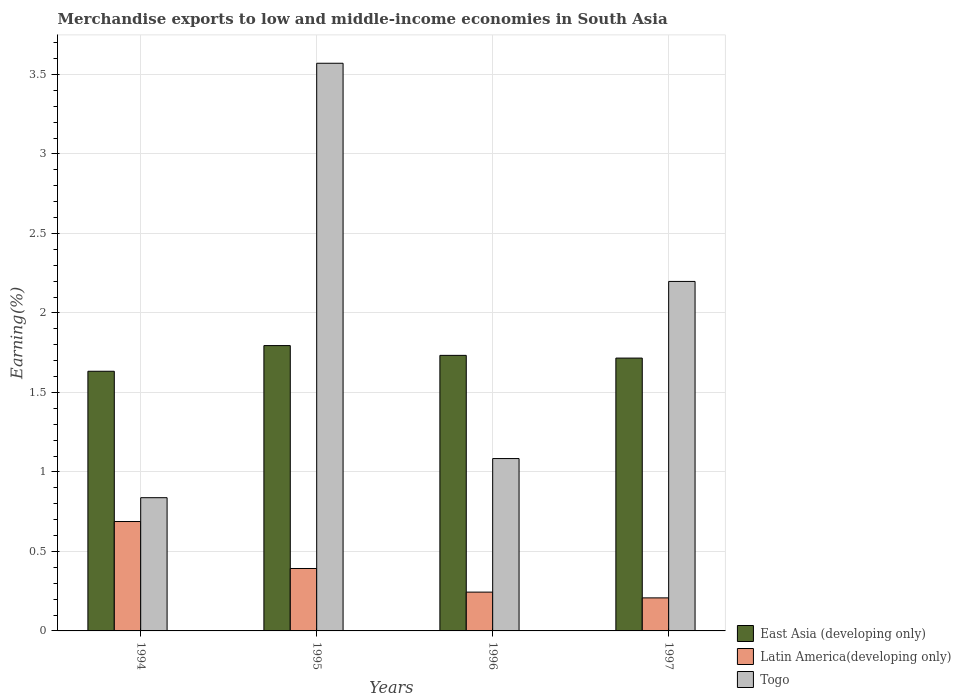How many groups of bars are there?
Offer a terse response. 4. What is the label of the 1st group of bars from the left?
Keep it short and to the point. 1994. In how many cases, is the number of bars for a given year not equal to the number of legend labels?
Offer a terse response. 0. What is the percentage of amount earned from merchandise exports in East Asia (developing only) in 1997?
Ensure brevity in your answer.  1.72. Across all years, what is the maximum percentage of amount earned from merchandise exports in Togo?
Ensure brevity in your answer.  3.57. Across all years, what is the minimum percentage of amount earned from merchandise exports in Latin America(developing only)?
Your response must be concise. 0.21. In which year was the percentage of amount earned from merchandise exports in East Asia (developing only) maximum?
Ensure brevity in your answer.  1995. What is the total percentage of amount earned from merchandise exports in East Asia (developing only) in the graph?
Provide a succinct answer. 6.88. What is the difference between the percentage of amount earned from merchandise exports in Latin America(developing only) in 1995 and that in 1997?
Provide a short and direct response. 0.18. What is the difference between the percentage of amount earned from merchandise exports in East Asia (developing only) in 1997 and the percentage of amount earned from merchandise exports in Latin America(developing only) in 1996?
Make the answer very short. 1.47. What is the average percentage of amount earned from merchandise exports in Latin America(developing only) per year?
Make the answer very short. 0.38. In the year 1995, what is the difference between the percentage of amount earned from merchandise exports in Latin America(developing only) and percentage of amount earned from merchandise exports in East Asia (developing only)?
Give a very brief answer. -1.4. In how many years, is the percentage of amount earned from merchandise exports in Togo greater than 2.2 %?
Your answer should be compact. 1. What is the ratio of the percentage of amount earned from merchandise exports in Latin America(developing only) in 1994 to that in 1995?
Offer a terse response. 1.75. What is the difference between the highest and the second highest percentage of amount earned from merchandise exports in Latin America(developing only)?
Your response must be concise. 0.3. What is the difference between the highest and the lowest percentage of amount earned from merchandise exports in Latin America(developing only)?
Make the answer very short. 0.48. In how many years, is the percentage of amount earned from merchandise exports in Togo greater than the average percentage of amount earned from merchandise exports in Togo taken over all years?
Keep it short and to the point. 2. Is the sum of the percentage of amount earned from merchandise exports in East Asia (developing only) in 1994 and 1995 greater than the maximum percentage of amount earned from merchandise exports in Togo across all years?
Keep it short and to the point. No. What does the 1st bar from the left in 1997 represents?
Your response must be concise. East Asia (developing only). What does the 3rd bar from the right in 1997 represents?
Your response must be concise. East Asia (developing only). How many years are there in the graph?
Your response must be concise. 4. Are the values on the major ticks of Y-axis written in scientific E-notation?
Your response must be concise. No. Does the graph contain any zero values?
Offer a terse response. No. Where does the legend appear in the graph?
Provide a short and direct response. Bottom right. How are the legend labels stacked?
Make the answer very short. Vertical. What is the title of the graph?
Provide a short and direct response. Merchandise exports to low and middle-income economies in South Asia. Does "Cabo Verde" appear as one of the legend labels in the graph?
Offer a very short reply. No. What is the label or title of the Y-axis?
Keep it short and to the point. Earning(%). What is the Earning(%) in East Asia (developing only) in 1994?
Your answer should be very brief. 1.63. What is the Earning(%) in Latin America(developing only) in 1994?
Offer a terse response. 0.69. What is the Earning(%) of Togo in 1994?
Provide a short and direct response. 0.84. What is the Earning(%) of East Asia (developing only) in 1995?
Make the answer very short. 1.79. What is the Earning(%) in Latin America(developing only) in 1995?
Offer a very short reply. 0.39. What is the Earning(%) of Togo in 1995?
Ensure brevity in your answer.  3.57. What is the Earning(%) of East Asia (developing only) in 1996?
Ensure brevity in your answer.  1.73. What is the Earning(%) of Latin America(developing only) in 1996?
Provide a succinct answer. 0.24. What is the Earning(%) of Togo in 1996?
Offer a very short reply. 1.08. What is the Earning(%) in East Asia (developing only) in 1997?
Offer a very short reply. 1.72. What is the Earning(%) of Latin America(developing only) in 1997?
Your answer should be compact. 0.21. What is the Earning(%) in Togo in 1997?
Provide a short and direct response. 2.2. Across all years, what is the maximum Earning(%) in East Asia (developing only)?
Your answer should be compact. 1.79. Across all years, what is the maximum Earning(%) of Latin America(developing only)?
Your answer should be very brief. 0.69. Across all years, what is the maximum Earning(%) of Togo?
Offer a terse response. 3.57. Across all years, what is the minimum Earning(%) of East Asia (developing only)?
Provide a succinct answer. 1.63. Across all years, what is the minimum Earning(%) of Latin America(developing only)?
Your response must be concise. 0.21. Across all years, what is the minimum Earning(%) in Togo?
Keep it short and to the point. 0.84. What is the total Earning(%) of East Asia (developing only) in the graph?
Give a very brief answer. 6.88. What is the total Earning(%) in Latin America(developing only) in the graph?
Your answer should be very brief. 1.53. What is the total Earning(%) in Togo in the graph?
Offer a terse response. 7.69. What is the difference between the Earning(%) of East Asia (developing only) in 1994 and that in 1995?
Offer a very short reply. -0.16. What is the difference between the Earning(%) of Latin America(developing only) in 1994 and that in 1995?
Your answer should be very brief. 0.3. What is the difference between the Earning(%) in Togo in 1994 and that in 1995?
Your answer should be very brief. -2.73. What is the difference between the Earning(%) of East Asia (developing only) in 1994 and that in 1996?
Offer a very short reply. -0.1. What is the difference between the Earning(%) of Latin America(developing only) in 1994 and that in 1996?
Make the answer very short. 0.44. What is the difference between the Earning(%) in Togo in 1994 and that in 1996?
Ensure brevity in your answer.  -0.25. What is the difference between the Earning(%) in East Asia (developing only) in 1994 and that in 1997?
Make the answer very short. -0.08. What is the difference between the Earning(%) in Latin America(developing only) in 1994 and that in 1997?
Give a very brief answer. 0.48. What is the difference between the Earning(%) of Togo in 1994 and that in 1997?
Your answer should be very brief. -1.36. What is the difference between the Earning(%) of East Asia (developing only) in 1995 and that in 1996?
Your answer should be compact. 0.06. What is the difference between the Earning(%) of Latin America(developing only) in 1995 and that in 1996?
Ensure brevity in your answer.  0.15. What is the difference between the Earning(%) of Togo in 1995 and that in 1996?
Your answer should be compact. 2.49. What is the difference between the Earning(%) of East Asia (developing only) in 1995 and that in 1997?
Your answer should be very brief. 0.08. What is the difference between the Earning(%) of Latin America(developing only) in 1995 and that in 1997?
Your answer should be compact. 0.18. What is the difference between the Earning(%) of Togo in 1995 and that in 1997?
Provide a succinct answer. 1.37. What is the difference between the Earning(%) of East Asia (developing only) in 1996 and that in 1997?
Your response must be concise. 0.02. What is the difference between the Earning(%) of Latin America(developing only) in 1996 and that in 1997?
Offer a very short reply. 0.04. What is the difference between the Earning(%) in Togo in 1996 and that in 1997?
Offer a very short reply. -1.11. What is the difference between the Earning(%) of East Asia (developing only) in 1994 and the Earning(%) of Latin America(developing only) in 1995?
Your answer should be compact. 1.24. What is the difference between the Earning(%) in East Asia (developing only) in 1994 and the Earning(%) in Togo in 1995?
Your answer should be very brief. -1.94. What is the difference between the Earning(%) in Latin America(developing only) in 1994 and the Earning(%) in Togo in 1995?
Make the answer very short. -2.88. What is the difference between the Earning(%) of East Asia (developing only) in 1994 and the Earning(%) of Latin America(developing only) in 1996?
Ensure brevity in your answer.  1.39. What is the difference between the Earning(%) in East Asia (developing only) in 1994 and the Earning(%) in Togo in 1996?
Ensure brevity in your answer.  0.55. What is the difference between the Earning(%) in Latin America(developing only) in 1994 and the Earning(%) in Togo in 1996?
Offer a very short reply. -0.4. What is the difference between the Earning(%) of East Asia (developing only) in 1994 and the Earning(%) of Latin America(developing only) in 1997?
Give a very brief answer. 1.43. What is the difference between the Earning(%) in East Asia (developing only) in 1994 and the Earning(%) in Togo in 1997?
Make the answer very short. -0.56. What is the difference between the Earning(%) of Latin America(developing only) in 1994 and the Earning(%) of Togo in 1997?
Your answer should be very brief. -1.51. What is the difference between the Earning(%) in East Asia (developing only) in 1995 and the Earning(%) in Latin America(developing only) in 1996?
Offer a very short reply. 1.55. What is the difference between the Earning(%) in East Asia (developing only) in 1995 and the Earning(%) in Togo in 1996?
Ensure brevity in your answer.  0.71. What is the difference between the Earning(%) in Latin America(developing only) in 1995 and the Earning(%) in Togo in 1996?
Provide a succinct answer. -0.69. What is the difference between the Earning(%) in East Asia (developing only) in 1995 and the Earning(%) in Latin America(developing only) in 1997?
Your answer should be compact. 1.59. What is the difference between the Earning(%) in East Asia (developing only) in 1995 and the Earning(%) in Togo in 1997?
Offer a very short reply. -0.4. What is the difference between the Earning(%) of Latin America(developing only) in 1995 and the Earning(%) of Togo in 1997?
Give a very brief answer. -1.81. What is the difference between the Earning(%) of East Asia (developing only) in 1996 and the Earning(%) of Latin America(developing only) in 1997?
Offer a very short reply. 1.53. What is the difference between the Earning(%) of East Asia (developing only) in 1996 and the Earning(%) of Togo in 1997?
Provide a succinct answer. -0.47. What is the difference between the Earning(%) in Latin America(developing only) in 1996 and the Earning(%) in Togo in 1997?
Your response must be concise. -1.95. What is the average Earning(%) of East Asia (developing only) per year?
Offer a terse response. 1.72. What is the average Earning(%) of Latin America(developing only) per year?
Your answer should be compact. 0.38. What is the average Earning(%) in Togo per year?
Keep it short and to the point. 1.92. In the year 1994, what is the difference between the Earning(%) of East Asia (developing only) and Earning(%) of Latin America(developing only)?
Your response must be concise. 0.95. In the year 1994, what is the difference between the Earning(%) of East Asia (developing only) and Earning(%) of Togo?
Make the answer very short. 0.8. In the year 1994, what is the difference between the Earning(%) in Latin America(developing only) and Earning(%) in Togo?
Your answer should be compact. -0.15. In the year 1995, what is the difference between the Earning(%) in East Asia (developing only) and Earning(%) in Latin America(developing only)?
Offer a very short reply. 1.4. In the year 1995, what is the difference between the Earning(%) in East Asia (developing only) and Earning(%) in Togo?
Provide a succinct answer. -1.78. In the year 1995, what is the difference between the Earning(%) in Latin America(developing only) and Earning(%) in Togo?
Provide a succinct answer. -3.18. In the year 1996, what is the difference between the Earning(%) in East Asia (developing only) and Earning(%) in Latin America(developing only)?
Provide a short and direct response. 1.49. In the year 1996, what is the difference between the Earning(%) in East Asia (developing only) and Earning(%) in Togo?
Provide a short and direct response. 0.65. In the year 1996, what is the difference between the Earning(%) in Latin America(developing only) and Earning(%) in Togo?
Give a very brief answer. -0.84. In the year 1997, what is the difference between the Earning(%) of East Asia (developing only) and Earning(%) of Latin America(developing only)?
Your answer should be very brief. 1.51. In the year 1997, what is the difference between the Earning(%) of East Asia (developing only) and Earning(%) of Togo?
Your response must be concise. -0.48. In the year 1997, what is the difference between the Earning(%) of Latin America(developing only) and Earning(%) of Togo?
Offer a very short reply. -1.99. What is the ratio of the Earning(%) in East Asia (developing only) in 1994 to that in 1995?
Provide a succinct answer. 0.91. What is the ratio of the Earning(%) of Latin America(developing only) in 1994 to that in 1995?
Ensure brevity in your answer.  1.75. What is the ratio of the Earning(%) in Togo in 1994 to that in 1995?
Provide a succinct answer. 0.23. What is the ratio of the Earning(%) of East Asia (developing only) in 1994 to that in 1996?
Your answer should be compact. 0.94. What is the ratio of the Earning(%) of Latin America(developing only) in 1994 to that in 1996?
Offer a very short reply. 2.82. What is the ratio of the Earning(%) in Togo in 1994 to that in 1996?
Offer a very short reply. 0.77. What is the ratio of the Earning(%) of East Asia (developing only) in 1994 to that in 1997?
Provide a succinct answer. 0.95. What is the ratio of the Earning(%) of Latin America(developing only) in 1994 to that in 1997?
Ensure brevity in your answer.  3.31. What is the ratio of the Earning(%) of Togo in 1994 to that in 1997?
Offer a terse response. 0.38. What is the ratio of the Earning(%) of East Asia (developing only) in 1995 to that in 1996?
Offer a terse response. 1.04. What is the ratio of the Earning(%) of Latin America(developing only) in 1995 to that in 1996?
Provide a short and direct response. 1.61. What is the ratio of the Earning(%) in Togo in 1995 to that in 1996?
Ensure brevity in your answer.  3.29. What is the ratio of the Earning(%) of East Asia (developing only) in 1995 to that in 1997?
Make the answer very short. 1.05. What is the ratio of the Earning(%) of Latin America(developing only) in 1995 to that in 1997?
Offer a terse response. 1.89. What is the ratio of the Earning(%) in Togo in 1995 to that in 1997?
Your answer should be very brief. 1.62. What is the ratio of the Earning(%) in Latin America(developing only) in 1996 to that in 1997?
Your response must be concise. 1.17. What is the ratio of the Earning(%) in Togo in 1996 to that in 1997?
Your response must be concise. 0.49. What is the difference between the highest and the second highest Earning(%) of East Asia (developing only)?
Ensure brevity in your answer.  0.06. What is the difference between the highest and the second highest Earning(%) in Latin America(developing only)?
Give a very brief answer. 0.3. What is the difference between the highest and the second highest Earning(%) of Togo?
Ensure brevity in your answer.  1.37. What is the difference between the highest and the lowest Earning(%) in East Asia (developing only)?
Make the answer very short. 0.16. What is the difference between the highest and the lowest Earning(%) of Latin America(developing only)?
Provide a succinct answer. 0.48. What is the difference between the highest and the lowest Earning(%) in Togo?
Your answer should be compact. 2.73. 